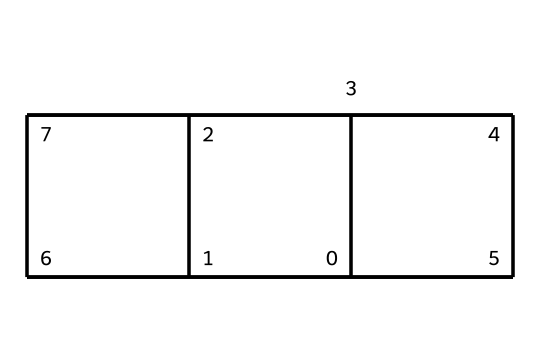What is the chemical name of this compound? The SMILES representation corresponds to the structural formula, and the specific arrangement of carbon atoms indicates this is cubane.
Answer: cubane How many carbon atoms are in cubane? By analyzing the SMILES representation, we can count the number of 'C' symbols, which is 8, indicating the presence of 8 carbon atoms in cubane.
Answer: 8 How many hydrogen atoms are in cubane? Each carbon in cubane is bonded to two hydrogens due to its saturated nature, resulting in a total of 16 hydrogen atoms (calculated as 2n + 2 for n=8).
Answer: 16 What type of strain is present in cubane? The unique cube structure of cubane creates significant angle strain due to the tetrahedral bond angles (109.5 degrees) being forced to 90 degrees, leading to high overall strain.
Answer: angle strain What is a primary application of cubane? Cubane’s high energy density and unique properties make it useful in the formulation of high-energy fuels and explosives, particularly in aerospace applications.
Answer: high-energy fuels What type of hydrocarbon is cubane classified as? Cubane is a saturated hydrocarbon since all carbon atoms are sp3 hybridized, and it possesses four bonds to hydrogen associated with each carbon.
Answer: saturated hydrocarbon 